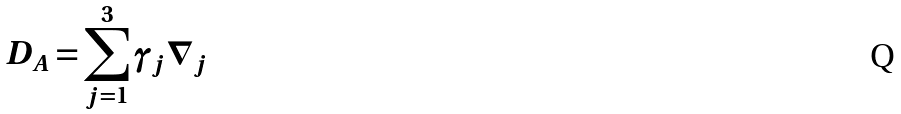<formula> <loc_0><loc_0><loc_500><loc_500>D _ { A } = \sum _ { j = 1 } ^ { 3 } \gamma _ { j } \nabla _ { j }</formula> 